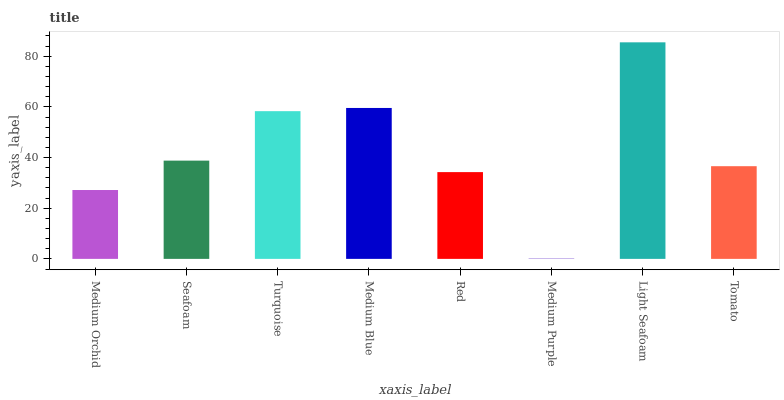Is Seafoam the minimum?
Answer yes or no. No. Is Seafoam the maximum?
Answer yes or no. No. Is Seafoam greater than Medium Orchid?
Answer yes or no. Yes. Is Medium Orchid less than Seafoam?
Answer yes or no. Yes. Is Medium Orchid greater than Seafoam?
Answer yes or no. No. Is Seafoam less than Medium Orchid?
Answer yes or no. No. Is Seafoam the high median?
Answer yes or no. Yes. Is Tomato the low median?
Answer yes or no. Yes. Is Medium Orchid the high median?
Answer yes or no. No. Is Turquoise the low median?
Answer yes or no. No. 